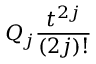Convert formula to latex. <formula><loc_0><loc_0><loc_500><loc_500>Q _ { j } \frac { t ^ { 2 j } } { ( 2 j ) ! }</formula> 